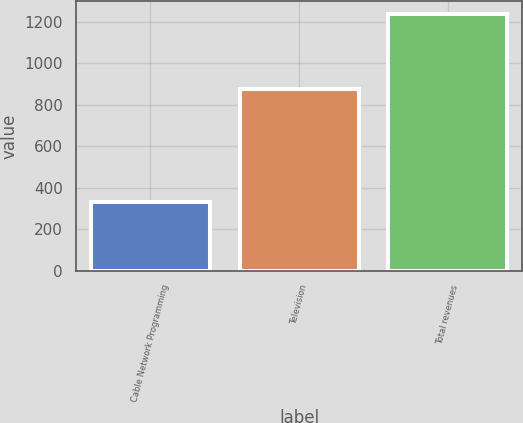<chart> <loc_0><loc_0><loc_500><loc_500><bar_chart><fcel>Cable Network Programming<fcel>Television<fcel>Total revenues<nl><fcel>332<fcel>873<fcel>1236<nl></chart> 